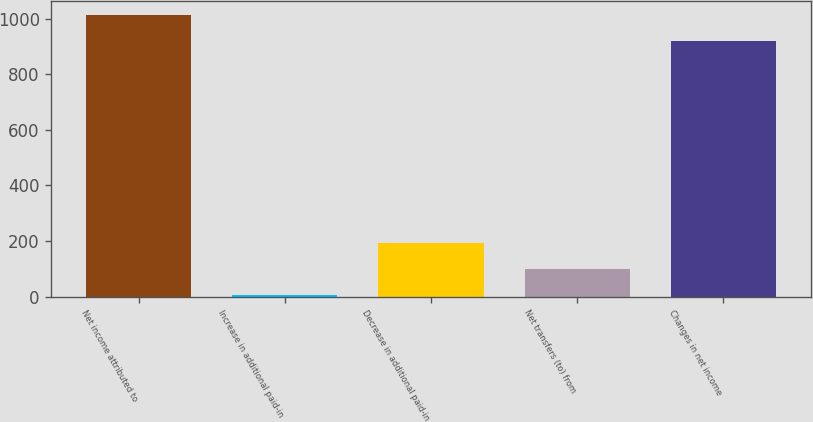Convert chart to OTSL. <chart><loc_0><loc_0><loc_500><loc_500><bar_chart><fcel>Net income attributed to<fcel>Increase in additional paid-in<fcel>Decrease in additional paid-in<fcel>Net transfers (to) from<fcel>Changes in net income<nl><fcel>1014.58<fcel>4.8<fcel>194.36<fcel>99.58<fcel>919.8<nl></chart> 